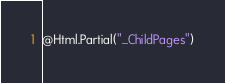Convert code to text. <code><loc_0><loc_0><loc_500><loc_500><_C#_>
@Html.Partial("_ChildPages")</code> 